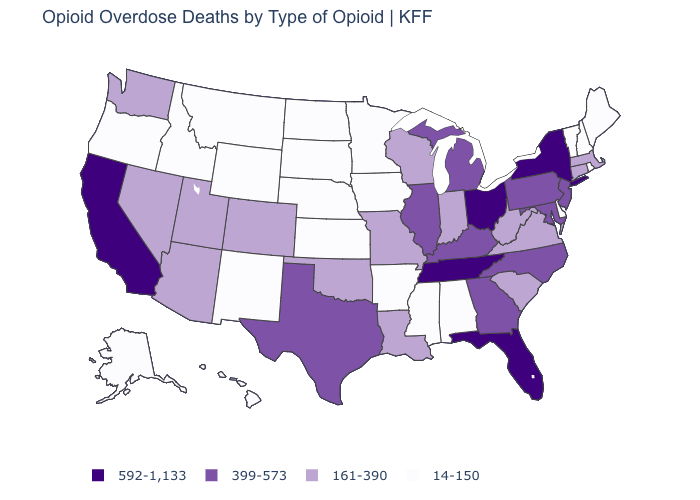Does Washington have a lower value than California?
Concise answer only. Yes. What is the lowest value in the MidWest?
Give a very brief answer. 14-150. How many symbols are there in the legend?
Concise answer only. 4. What is the value of North Carolina?
Answer briefly. 399-573. Does Tennessee have the highest value in the USA?
Quick response, please. Yes. What is the value of Maryland?
Keep it brief. 399-573. Among the states that border Minnesota , which have the lowest value?
Be succinct. Iowa, North Dakota, South Dakota. Among the states that border Florida , which have the highest value?
Be succinct. Georgia. Among the states that border Connecticut , which have the highest value?
Write a very short answer. New York. Which states have the lowest value in the USA?
Quick response, please. Alabama, Alaska, Arkansas, Delaware, Hawaii, Idaho, Iowa, Kansas, Maine, Minnesota, Mississippi, Montana, Nebraska, New Hampshire, New Mexico, North Dakota, Oregon, Rhode Island, South Dakota, Vermont, Wyoming. What is the highest value in the West ?
Write a very short answer. 592-1,133. Which states hav the highest value in the South?
Keep it brief. Florida, Tennessee. Name the states that have a value in the range 592-1,133?
Keep it brief. California, Florida, New York, Ohio, Tennessee. What is the lowest value in states that border Minnesota?
Concise answer only. 14-150. 